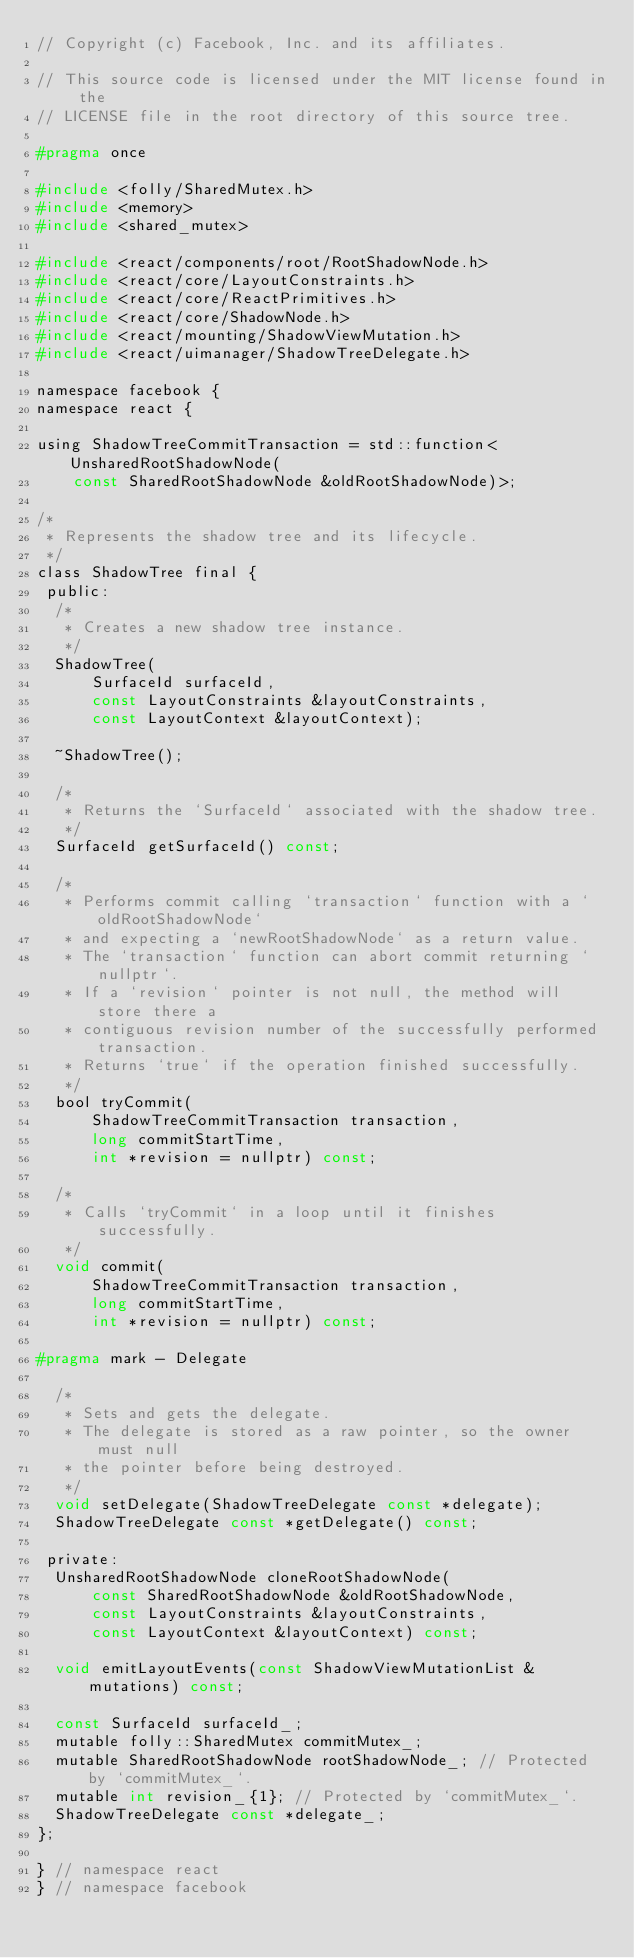<code> <loc_0><loc_0><loc_500><loc_500><_C_>// Copyright (c) Facebook, Inc. and its affiliates.

// This source code is licensed under the MIT license found in the
// LICENSE file in the root directory of this source tree.

#pragma once

#include <folly/SharedMutex.h>
#include <memory>
#include <shared_mutex>

#include <react/components/root/RootShadowNode.h>
#include <react/core/LayoutConstraints.h>
#include <react/core/ReactPrimitives.h>
#include <react/core/ShadowNode.h>
#include <react/mounting/ShadowViewMutation.h>
#include <react/uimanager/ShadowTreeDelegate.h>

namespace facebook {
namespace react {

using ShadowTreeCommitTransaction = std::function<UnsharedRootShadowNode(
    const SharedRootShadowNode &oldRootShadowNode)>;

/*
 * Represents the shadow tree and its lifecycle.
 */
class ShadowTree final {
 public:
  /*
   * Creates a new shadow tree instance.
   */
  ShadowTree(
      SurfaceId surfaceId,
      const LayoutConstraints &layoutConstraints,
      const LayoutContext &layoutContext);

  ~ShadowTree();

  /*
   * Returns the `SurfaceId` associated with the shadow tree.
   */
  SurfaceId getSurfaceId() const;

  /*
   * Performs commit calling `transaction` function with a `oldRootShadowNode`
   * and expecting a `newRootShadowNode` as a return value.
   * The `transaction` function can abort commit returning `nullptr`.
   * If a `revision` pointer is not null, the method will store there a
   * contiguous revision number of the successfully performed transaction.
   * Returns `true` if the operation finished successfully.
   */
  bool tryCommit(
      ShadowTreeCommitTransaction transaction,
      long commitStartTime,
      int *revision = nullptr) const;

  /*
   * Calls `tryCommit` in a loop until it finishes successfully.
   */
  void commit(
      ShadowTreeCommitTransaction transaction,
      long commitStartTime,
      int *revision = nullptr) const;

#pragma mark - Delegate

  /*
   * Sets and gets the delegate.
   * The delegate is stored as a raw pointer, so the owner must null
   * the pointer before being destroyed.
   */
  void setDelegate(ShadowTreeDelegate const *delegate);
  ShadowTreeDelegate const *getDelegate() const;

 private:
  UnsharedRootShadowNode cloneRootShadowNode(
      const SharedRootShadowNode &oldRootShadowNode,
      const LayoutConstraints &layoutConstraints,
      const LayoutContext &layoutContext) const;

  void emitLayoutEvents(const ShadowViewMutationList &mutations) const;

  const SurfaceId surfaceId_;
  mutable folly::SharedMutex commitMutex_;
  mutable SharedRootShadowNode rootShadowNode_; // Protected by `commitMutex_`.
  mutable int revision_{1}; // Protected by `commitMutex_`.
  ShadowTreeDelegate const *delegate_;
};

} // namespace react
} // namespace facebook
</code> 